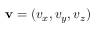Convert formula to latex. <formula><loc_0><loc_0><loc_500><loc_500>v = ( v _ { x } , v _ { y } , v _ { z } )</formula> 